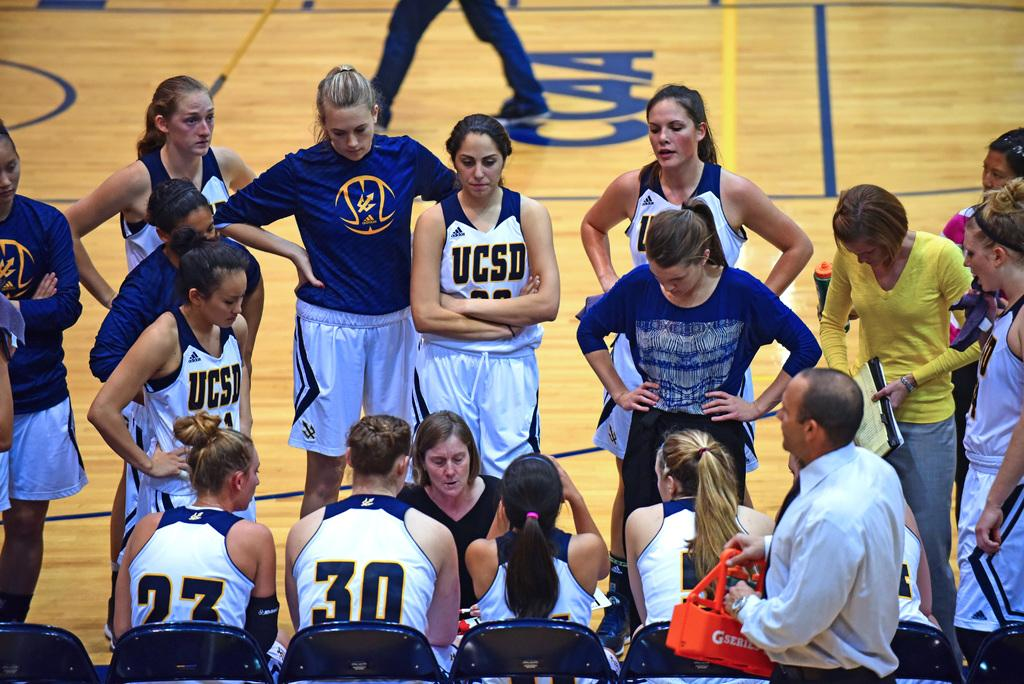<image>
Share a concise interpretation of the image provided. Basketball player wearing a jersey which says UCSD. 